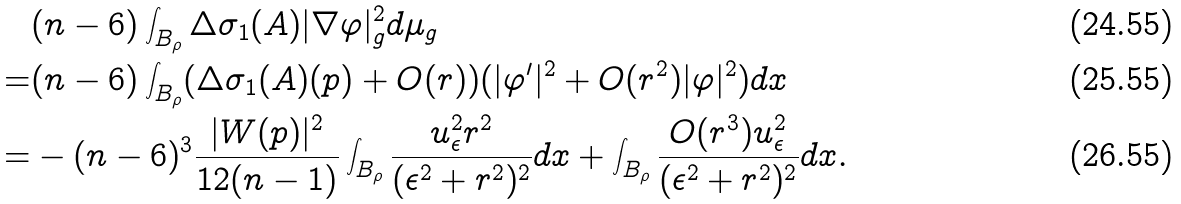<formula> <loc_0><loc_0><loc_500><loc_500>& ( n - 6 ) \int _ { B _ { \rho } } \Delta \sigma _ { 1 } ( A ) | \nabla \varphi | _ { g } ^ { 2 } d \mu _ { g } \\ = & ( n - 6 ) \int _ { B _ { \rho } } ( \Delta \sigma _ { 1 } ( A ) ( p ) + O ( r ) ) ( | \varphi ^ { \prime } | ^ { 2 } + O ( r ^ { 2 } ) | \varphi | ^ { 2 } ) d x \\ = & - ( n - 6 ) ^ { 3 } \frac { | W ( p ) | ^ { 2 } } { 1 2 ( n - 1 ) } \int _ { B _ { \rho } } \frac { u _ { \epsilon } ^ { 2 } r ^ { 2 } } { ( \epsilon ^ { 2 } + r ^ { 2 } ) ^ { 2 } } d x + \int _ { B _ { \rho } } \frac { O ( r ^ { 3 } ) u _ { \epsilon } ^ { 2 } } { ( \epsilon ^ { 2 } + r ^ { 2 } ) ^ { 2 } } d x .</formula> 